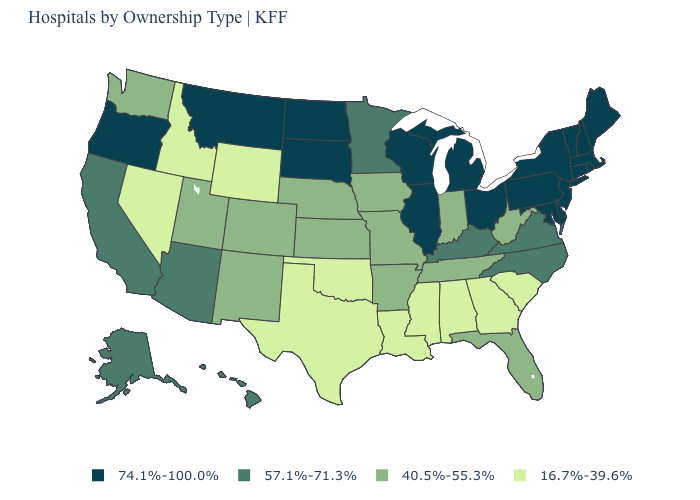Among the states that border Florida , which have the lowest value?
Answer briefly. Alabama, Georgia. What is the value of Maryland?
Write a very short answer. 74.1%-100.0%. What is the value of Wisconsin?
Concise answer only. 74.1%-100.0%. Is the legend a continuous bar?
Keep it brief. No. Among the states that border Washington , which have the highest value?
Concise answer only. Oregon. Name the states that have a value in the range 40.5%-55.3%?
Concise answer only. Arkansas, Colorado, Florida, Indiana, Iowa, Kansas, Missouri, Nebraska, New Mexico, Tennessee, Utah, Washington, West Virginia. What is the highest value in the South ?
Short answer required. 74.1%-100.0%. Name the states that have a value in the range 74.1%-100.0%?
Give a very brief answer. Connecticut, Delaware, Illinois, Maine, Maryland, Massachusetts, Michigan, Montana, New Hampshire, New Jersey, New York, North Dakota, Ohio, Oregon, Pennsylvania, Rhode Island, South Dakota, Vermont, Wisconsin. What is the value of Alabama?
Be succinct. 16.7%-39.6%. Name the states that have a value in the range 16.7%-39.6%?
Short answer required. Alabama, Georgia, Idaho, Louisiana, Mississippi, Nevada, Oklahoma, South Carolina, Texas, Wyoming. Which states have the lowest value in the South?
Write a very short answer. Alabama, Georgia, Louisiana, Mississippi, Oklahoma, South Carolina, Texas. Which states have the lowest value in the USA?
Be succinct. Alabama, Georgia, Idaho, Louisiana, Mississippi, Nevada, Oklahoma, South Carolina, Texas, Wyoming. Name the states that have a value in the range 16.7%-39.6%?
Concise answer only. Alabama, Georgia, Idaho, Louisiana, Mississippi, Nevada, Oklahoma, South Carolina, Texas, Wyoming. Which states have the highest value in the USA?
Quick response, please. Connecticut, Delaware, Illinois, Maine, Maryland, Massachusetts, Michigan, Montana, New Hampshire, New Jersey, New York, North Dakota, Ohio, Oregon, Pennsylvania, Rhode Island, South Dakota, Vermont, Wisconsin. Name the states that have a value in the range 16.7%-39.6%?
Write a very short answer. Alabama, Georgia, Idaho, Louisiana, Mississippi, Nevada, Oklahoma, South Carolina, Texas, Wyoming. 